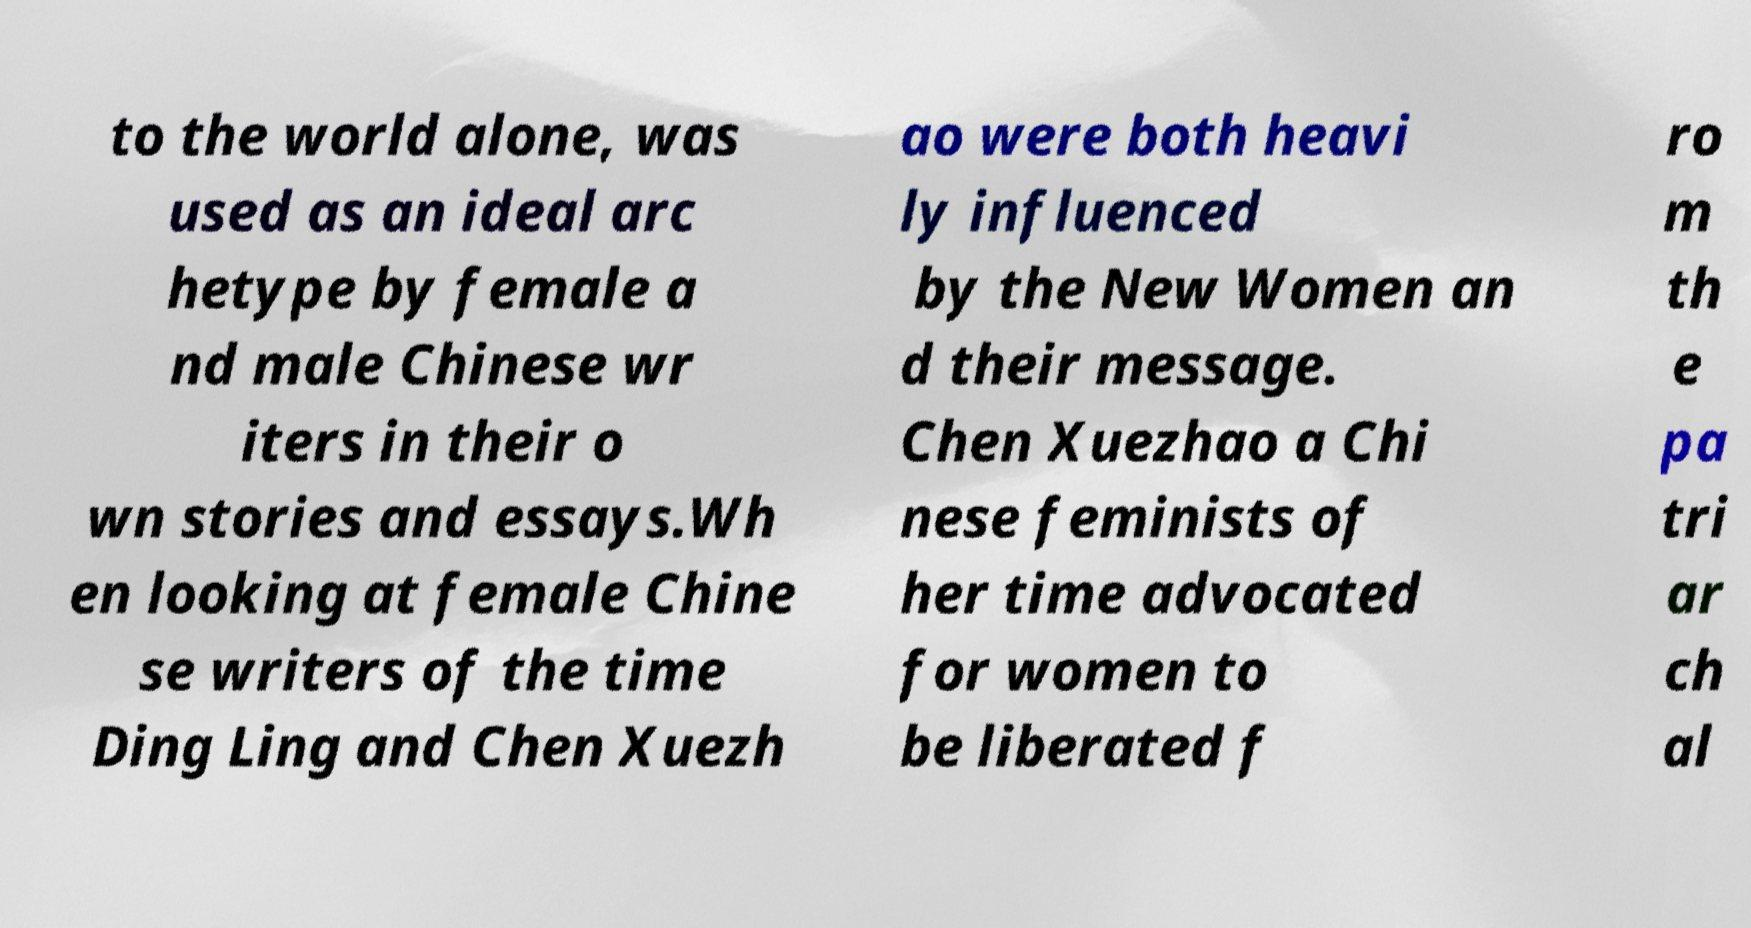Can you read and provide the text displayed in the image?This photo seems to have some interesting text. Can you extract and type it out for me? to the world alone, was used as an ideal arc hetype by female a nd male Chinese wr iters in their o wn stories and essays.Wh en looking at female Chine se writers of the time Ding Ling and Chen Xuezh ao were both heavi ly influenced by the New Women an d their message. Chen Xuezhao a Chi nese feminists of her time advocated for women to be liberated f ro m th e pa tri ar ch al 